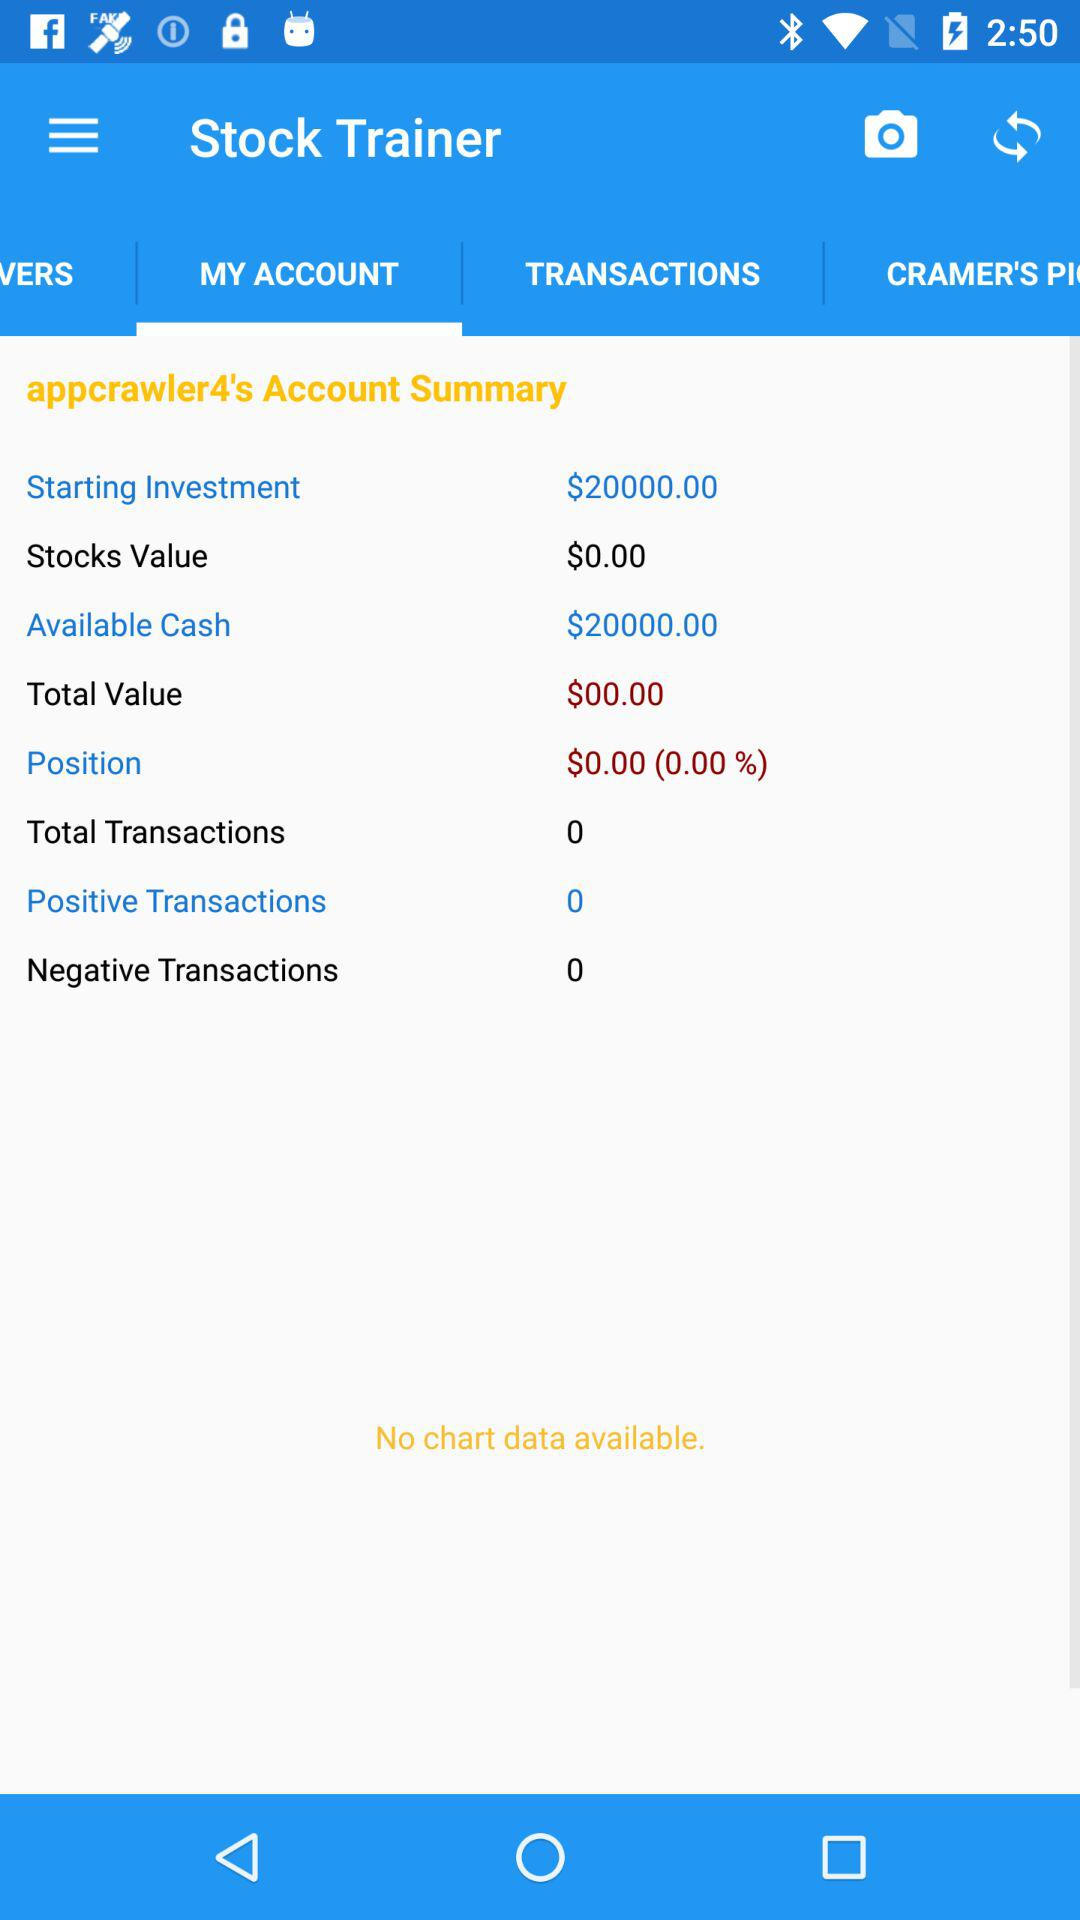Which option is selected in "Stock Trainer"? The option that is selected in "Stock Trainer" is "MY ACCOUNT". 